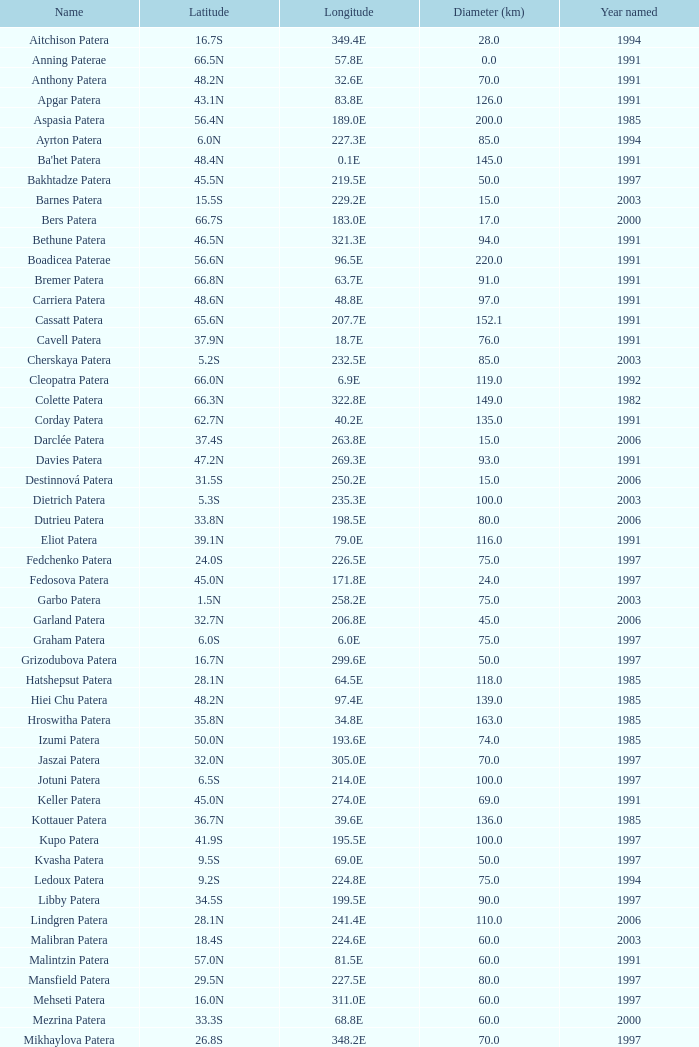What is the average Year Named, when Latitude is 37.9N, and when Diameter (km) is greater than 76? None. 